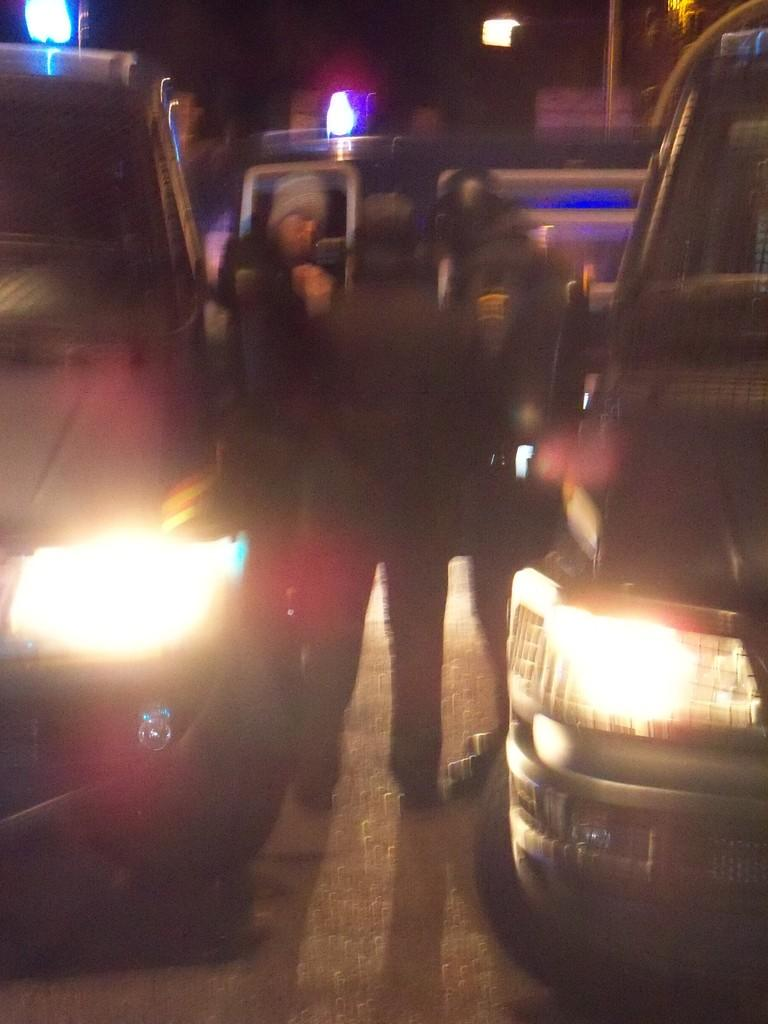What type of vehicles can be seen in the image? There are cars in the image. What else is present on the road in the image? There are people on the road in the image. What type of lighting is present along the road in the image? There are street lights in the image. How many quarters can be seen on the road in the image? There are no quarters visible on the road in the image. What type of leaf is present on the road in the image? There are no leaves present on the road in the image. 